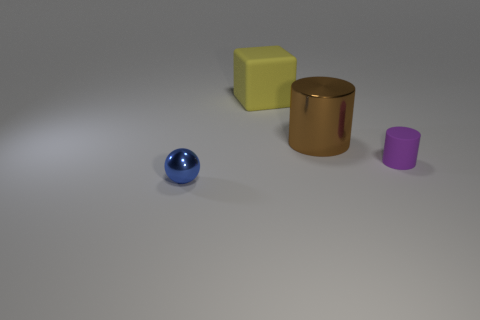Add 3 large cyan blocks. How many objects exist? 7 Subtract all cubes. How many objects are left? 3 Add 1 large things. How many large things exist? 3 Subtract 0 green blocks. How many objects are left? 4 Subtract all brown objects. Subtract all tiny rubber cylinders. How many objects are left? 2 Add 1 blocks. How many blocks are left? 2 